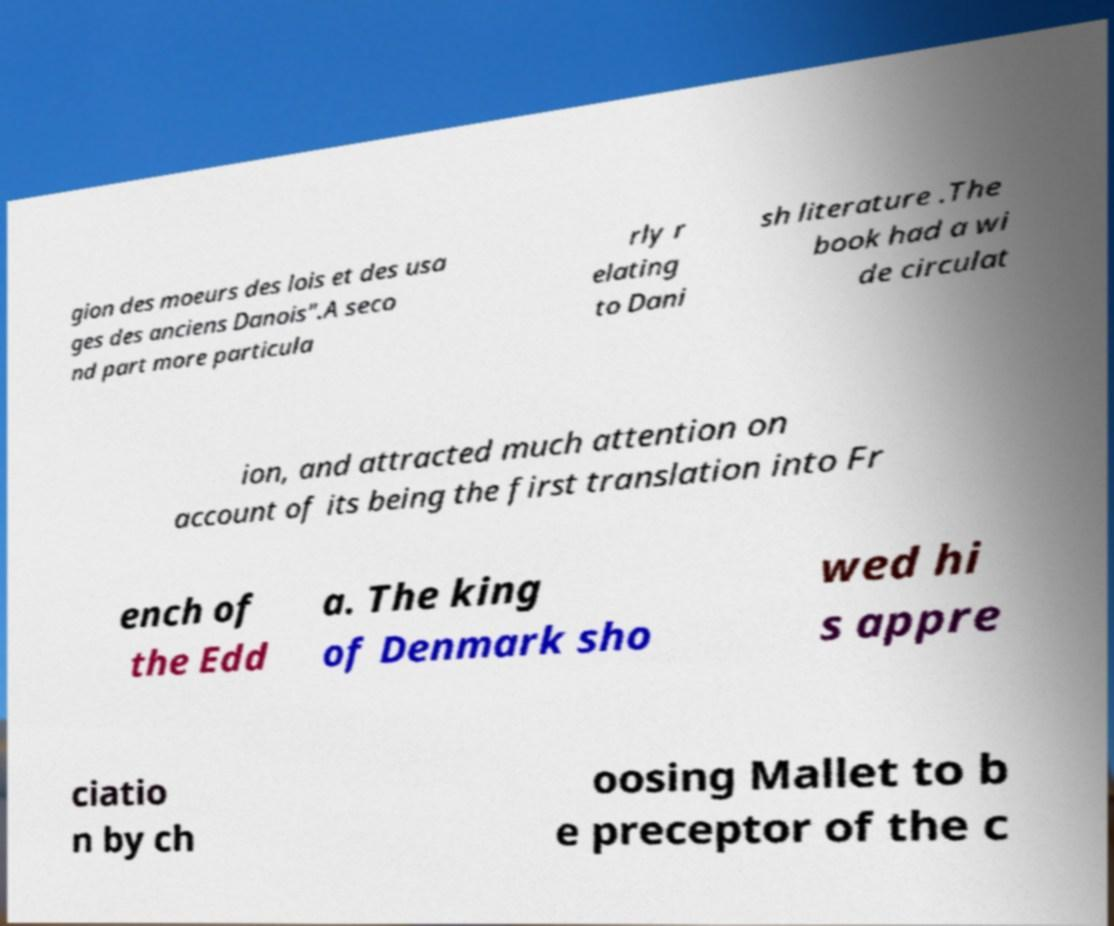I need the written content from this picture converted into text. Can you do that? gion des moeurs des lois et des usa ges des anciens Danois".A seco nd part more particula rly r elating to Dani sh literature .The book had a wi de circulat ion, and attracted much attention on account of its being the first translation into Fr ench of the Edd a. The king of Denmark sho wed hi s appre ciatio n by ch oosing Mallet to b e preceptor of the c 